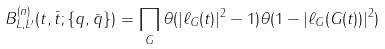<formula> <loc_0><loc_0><loc_500><loc_500>B _ { L , L ^ { \prime } } ^ { ( n ) } ( t , \bar { t } ; \{ q , \bar { q } \} ) = \prod _ { G } \theta ( | \ell _ { G } ( t ) | ^ { 2 } - 1 ) \theta ( 1 - | \ell _ { G } ( G ( t ) ) | ^ { 2 } )</formula> 